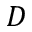Convert formula to latex. <formula><loc_0><loc_0><loc_500><loc_500>D</formula> 